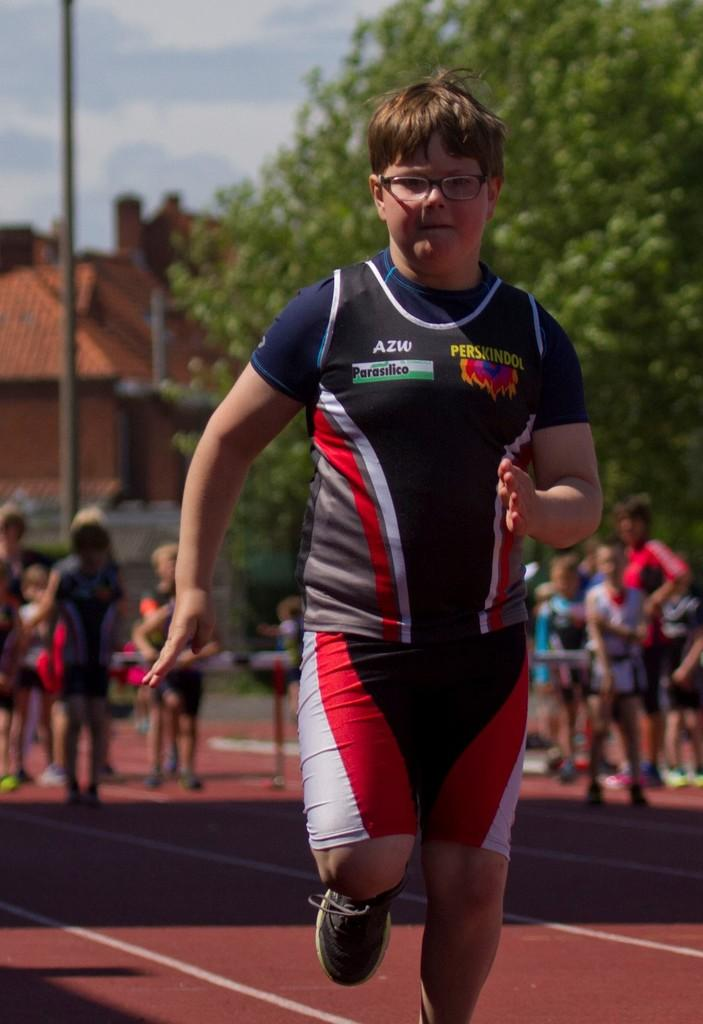What is the boy in the image doing? The boy is running on the track. What are the group of people in the image doing? The group of people is standing. What structure is present in the image? There is a building in the image. What type of vegetation can be seen in the background? There is a tree in the background. What is visible in the sky in the image? The sky is visible in the image. What type of sign can be seen at the party in the image? There is no party or sign present in the image. What is the boy using to eat the ice cream in the image? There is no ice cream or spoon present in the image. 